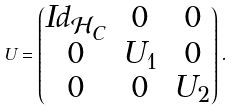<formula> <loc_0><loc_0><loc_500><loc_500>U = \begin{pmatrix} I d _ { \mathcal { H } _ { C } } & 0 & 0 \\ 0 & U _ { 1 } & 0 \\ 0 & 0 & U _ { 2 } \end{pmatrix} .</formula> 